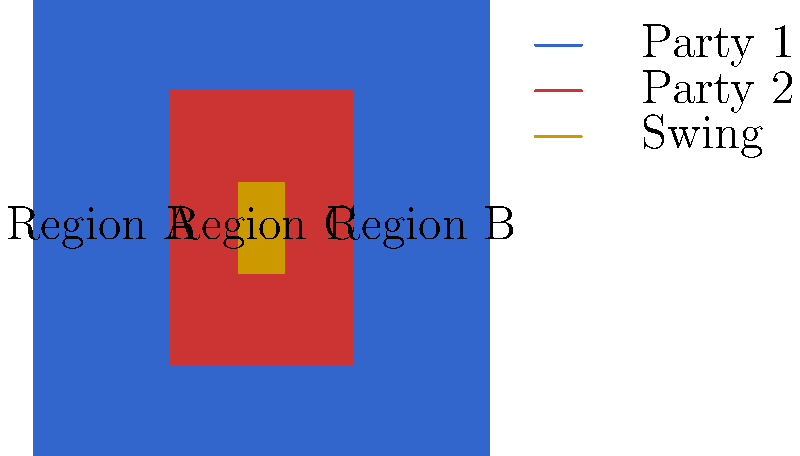Based on the election result map shown, which region is most likely to be considered a "swing region" in future elections, and why is this significant for campaign strategies? To identify the swing region and understand its significance, let's analyze the map step-by-step:

1. The map shows three distinct regions:
   - Region A (outer area): Colored blue, indicating strong support for Party 1
   - Region B (inner rectangle): Colored red, showing strong support for Party 2
   - Region C (small central area): Colored orange, suggesting a mixed or swing area

2. Region C is the swing region because:
   - It's located between the strongholds of both parties
   - Its color (orange) indicates a mix of support or close results between parties

3. Significance for campaign strategies:
   a) Targeted campaigning: Parties will focus resources and time on Region C, as it's most likely to change allegiance
   b) Tailored messaging: Campaigns will craft messages that appeal to the specific concerns of voters in Region C
   c) Voter turnout efforts: Both parties will intensify get-out-the-vote efforts in Region C
   d) Coalition building: Parties may seek alliances with local leaders or interest groups in Region C
   e) Resource allocation: More campaign funds and staff will be allocated to Region C compared to safe regions

4. Impact on election outcomes:
   - Region C, despite its small size, could determine the overall election result
   - Small shifts in voter preference in Region C could lead to significant changes in the electoral map

5. Long-term strategy:
   - Parties will monitor demographic and economic changes in Region C to anticipate future voting trends
   - Policy proposals may be tailored to address the specific needs of Region C's population

Understanding swing regions like Region C is crucial for journalists covering elections, as these areas often become the focus of intense political activity and media attention.
Answer: Region C; it's crucial for targeted campaigning, resource allocation, and could determine election outcomes. 